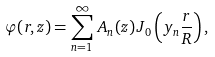Convert formula to latex. <formula><loc_0><loc_0><loc_500><loc_500>\varphi ( r , z ) = \sum _ { n = 1 } ^ { \infty } \, A _ { n } ( z ) \, J _ { 0 } \left ( y _ { n } \frac { r } { R } \right ) ,</formula> 